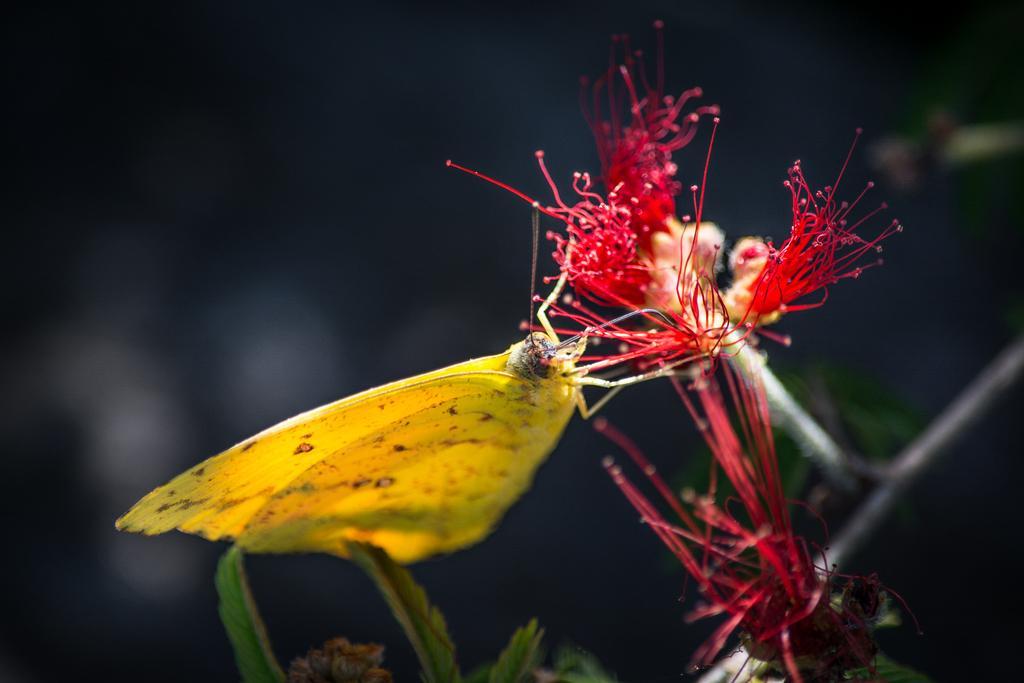Describe this image in one or two sentences. In this image I can see a yellow color butterfly on the red color flower. I can see few green leaves and black background. 